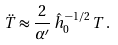Convert formula to latex. <formula><loc_0><loc_0><loc_500><loc_500>\ddot { T } \approx \frac { 2 } { \alpha ^ { \prime } } \, \hat { h } ^ { - 1 / 2 } _ { 0 } \, T \, .</formula> 